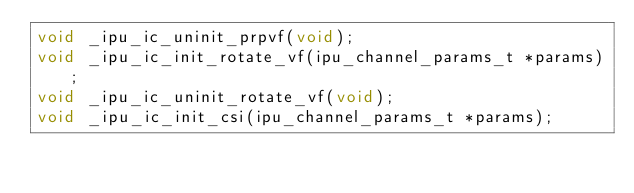<code> <loc_0><loc_0><loc_500><loc_500><_C_>void _ipu_ic_uninit_prpvf(void);
void _ipu_ic_init_rotate_vf(ipu_channel_params_t *params);
void _ipu_ic_uninit_rotate_vf(void);
void _ipu_ic_init_csi(ipu_channel_params_t *params);</code> 